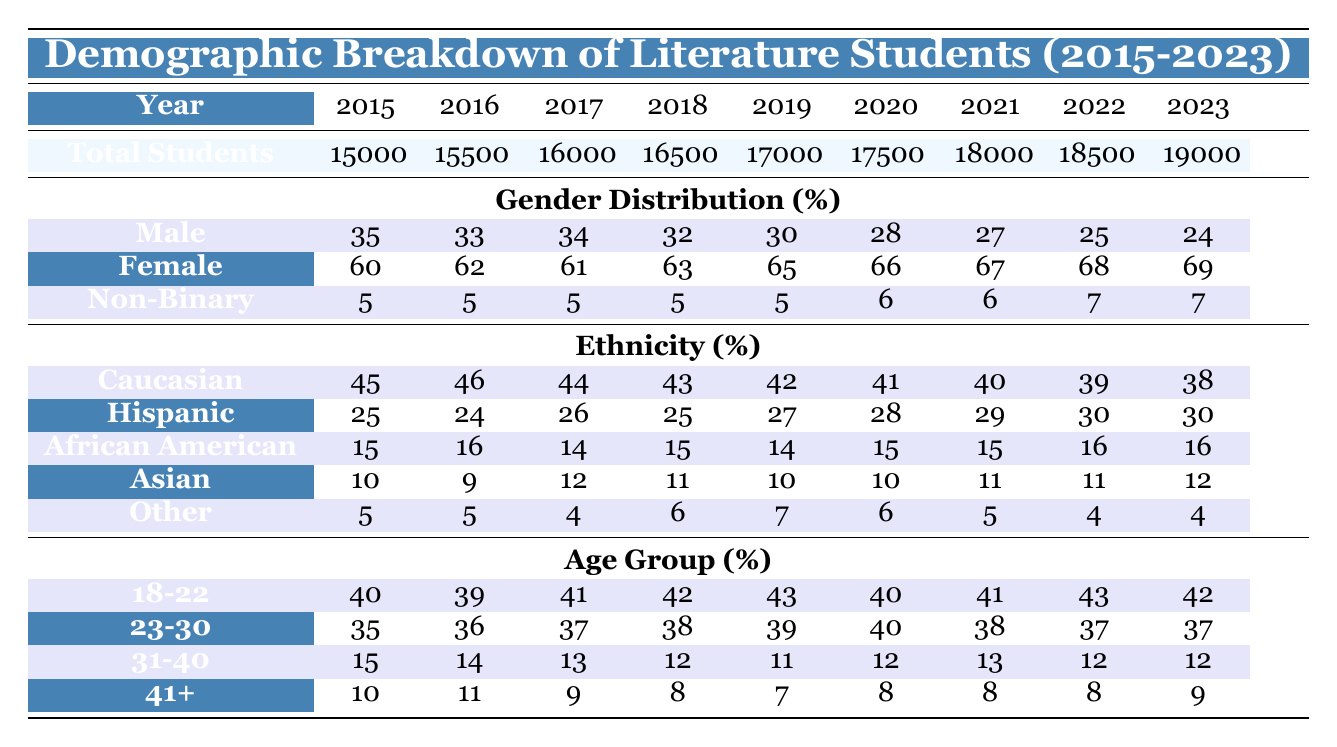What was the total number of literature students in 2020? In 2020, the table lists the total number of literature students as 17500. This value is directly shown in the respective row for total students in that year.
Answer: 17500 Which year had the highest percentage of female students? By examining the Gender Distribution section, we can see that the percentage of female students was highest in 2023 at 69%. This is the highest percentage compared to the previous years listed.
Answer: 69 What is the change in the percentage of Caucasian students from 2015 to 2023? The percentage of Caucasian students in 2015 was 45% and in 2023 it was 38%. To find the change, we subtract the 2023 percentage from the 2015 percentage: 45 - 38 = 7. This indicates a decrease of 7 percentage points over the period.
Answer: 7 In which age group did the largest percentage of students fall in 2019? For the year 2019, the Age Group row shows that the highest percentage of students (43%) belonged to the 18-22 age group, which is greater than the other age groups displayed.
Answer: 18-22 Was the percentage of non-binary students consistent across all years? Reviewing the Gender Distribution, the percentage of non-binary students remained at 5% for the years 2015 to 2019 and slightly increased to 6% in 2020 and then to 7% in both 2021 and 2022. Thus, it was consistent for most years but had a slight increase in the latter years.
Answer: No 